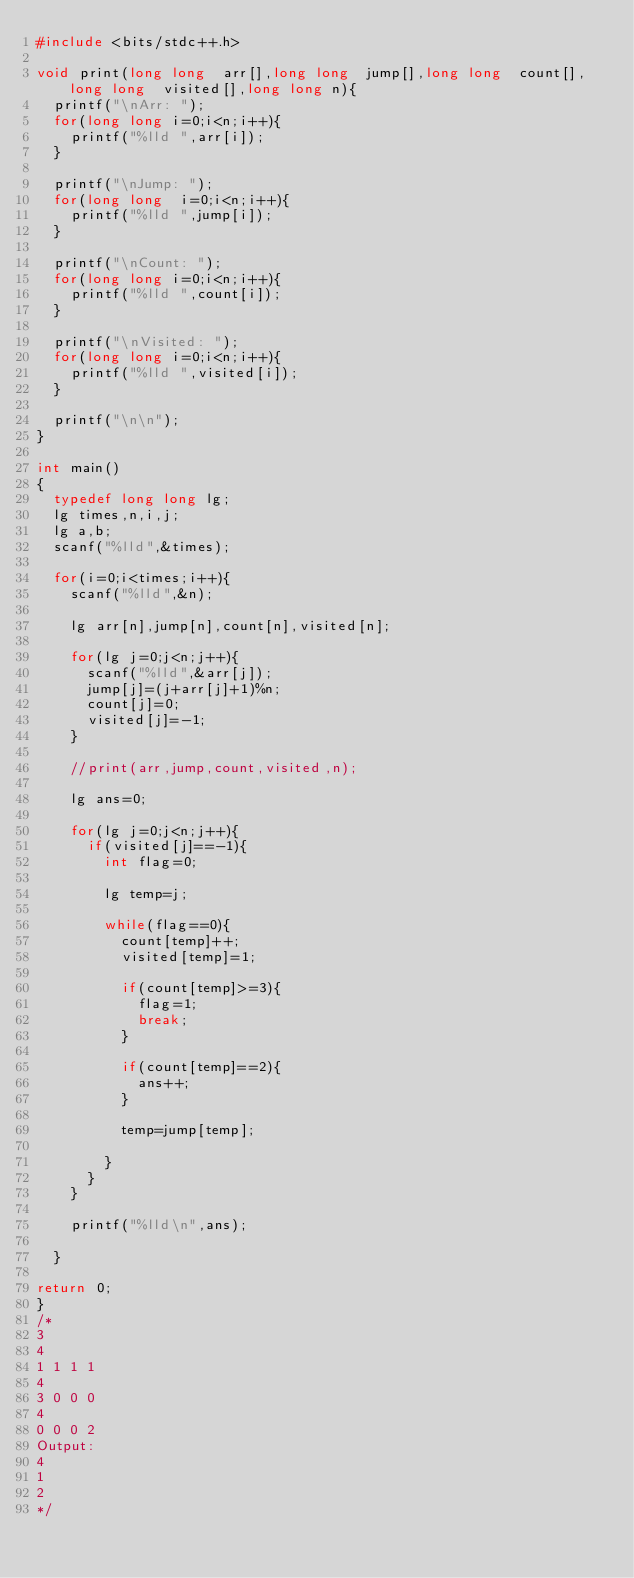<code> <loc_0><loc_0><loc_500><loc_500><_C++_>#include <bits/stdc++.h>

void print(long long  arr[],long long  jump[],long long  count[],long long  visited[],long long n){
	printf("\nArr: ");
	for(long long i=0;i<n;i++){
		printf("%lld ",arr[i]);
	}

	printf("\nJump: ");
	for(long long  i=0;i<n;i++){
		printf("%lld ",jump[i]);
	}

	printf("\nCount: ");
	for(long long i=0;i<n;i++){
		printf("%lld ",count[i]);
	}

	printf("\nVisited: ");
	for(long long i=0;i<n;i++){
		printf("%lld ",visited[i]);
	}

	printf("\n\n");
}

int main()
{
	typedef long long lg;
	lg times,n,i,j;
	lg a,b;
	scanf("%lld",&times);
	
	for(i=0;i<times;i++){
		scanf("%lld",&n);

		lg arr[n],jump[n],count[n],visited[n];

		for(lg j=0;j<n;j++){
			scanf("%lld",&arr[j]);
			jump[j]=(j+arr[j]+1)%n;
			count[j]=0;
			visited[j]=-1;
		}

		//print(arr,jump,count,visited,n);

		lg ans=0;

		for(lg j=0;j<n;j++){
			if(visited[j]==-1){
				int flag=0;

				lg temp=j;

				while(flag==0){
					count[temp]++;
					visited[temp]=1;

					if(count[temp]>=3){
						flag=1;
						break;
					}

					if(count[temp]==2){
						ans++;
					}
					
					temp=jump[temp];

				}
			}
		}

		printf("%lld\n",ans);

	}

return 0;
}
/*
3
4
1 1 1 1
4
3 0 0 0
4
0 0 0 2
Output:
4
1
2
*/
</code> 